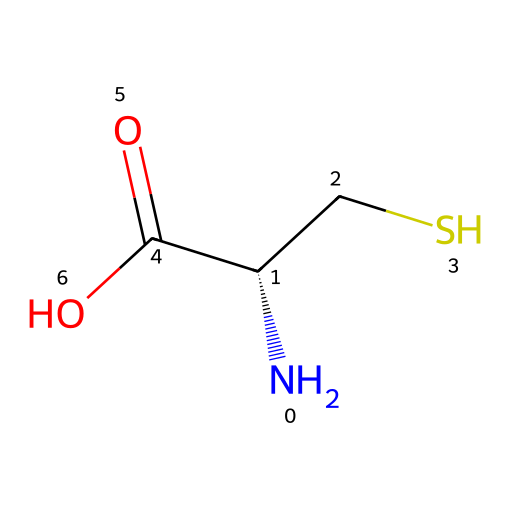How many carbon atoms are in cysteine? In the SMILES representation, we look for the 'C' symbols. There are two 'C' atoms visible in the structure, indicating the number of carbon atoms.
Answer: 2 What functional group is present in cysteine? The SMILES notation contains a 'SH' which indicates the presence of a thiol group. This is a characteristic feature of cysteine, a type of functional group.
Answer: thiol How many nitrogen atoms are in cysteine? There is a single 'N' in the SMILES representation, which signifies the presence of one nitrogen atom in the cysteine molecule.
Answer: 1 What is the total number of hydrogen atoms in cysteine? We analyze the structure by counting the hydrogen atoms implied in the SMILES notation. Considering the carbon, nitrogen, and sulfur connectivity, there are 7 hydrogen atoms connected overall.
Answer: 7 What is the molecular formula of cysteine? By analyzing the components in the SMILES, we tally the atoms: 3 carbons, 7 hydrogens, 1 nitrogen, 1 oxygen, 1 sulfur. This leads us to the molecular formula C3H7NO2S.
Answer: C3H7NO2S What distinguishes cysteine from other amino acids? Cysteine contains a thiol group (-SH) at the end of its side chain, which is not present in most other amino acids, setting it apart in terms of chemical properties and structure.
Answer: thiol group 